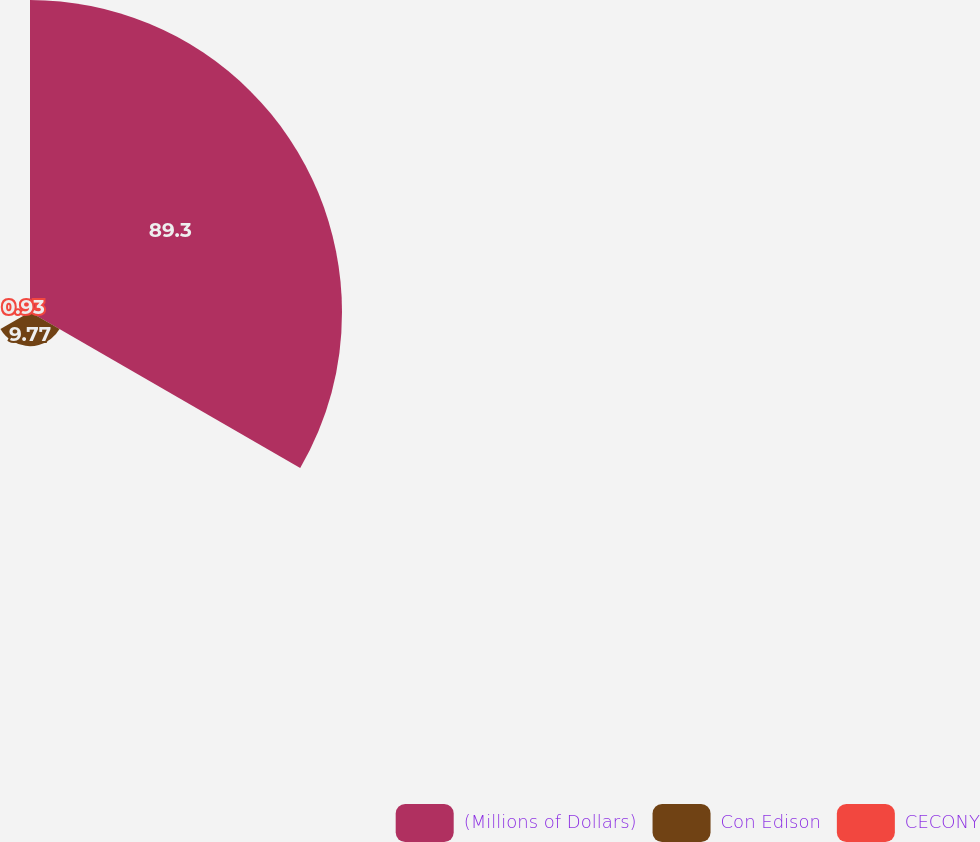Convert chart to OTSL. <chart><loc_0><loc_0><loc_500><loc_500><pie_chart><fcel>(Millions of Dollars)<fcel>Con Edison<fcel>CECONY<nl><fcel>89.3%<fcel>9.77%<fcel>0.93%<nl></chart> 